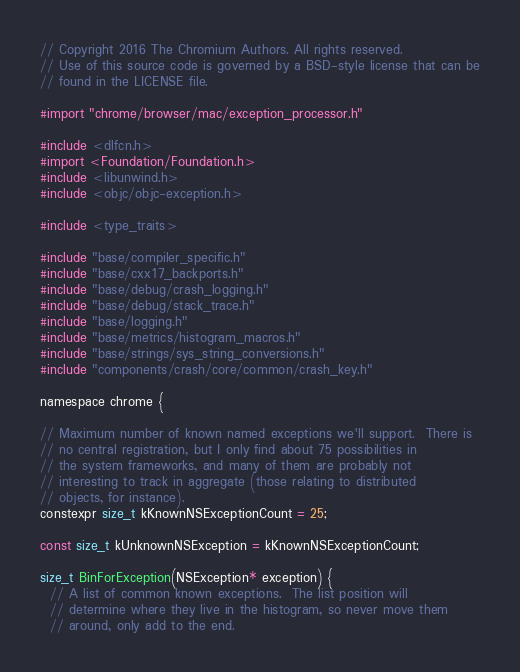Convert code to text. <code><loc_0><loc_0><loc_500><loc_500><_ObjectiveC_>// Copyright 2016 The Chromium Authors. All rights reserved.
// Use of this source code is governed by a BSD-style license that can be
// found in the LICENSE file.

#import "chrome/browser/mac/exception_processor.h"

#include <dlfcn.h>
#import <Foundation/Foundation.h>
#include <libunwind.h>
#include <objc/objc-exception.h>

#include <type_traits>

#include "base/compiler_specific.h"
#include "base/cxx17_backports.h"
#include "base/debug/crash_logging.h"
#include "base/debug/stack_trace.h"
#include "base/logging.h"
#include "base/metrics/histogram_macros.h"
#include "base/strings/sys_string_conversions.h"
#include "components/crash/core/common/crash_key.h"

namespace chrome {

// Maximum number of known named exceptions we'll support.  There is
// no central registration, but I only find about 75 possibilities in
// the system frameworks, and many of them are probably not
// interesting to track in aggregate (those relating to distributed
// objects, for instance).
constexpr size_t kKnownNSExceptionCount = 25;

const size_t kUnknownNSException = kKnownNSExceptionCount;

size_t BinForException(NSException* exception) {
  // A list of common known exceptions.  The list position will
  // determine where they live in the histogram, so never move them
  // around, only add to the end.</code> 